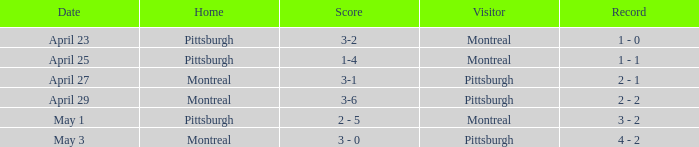What was the score on April 25? 1-4. 